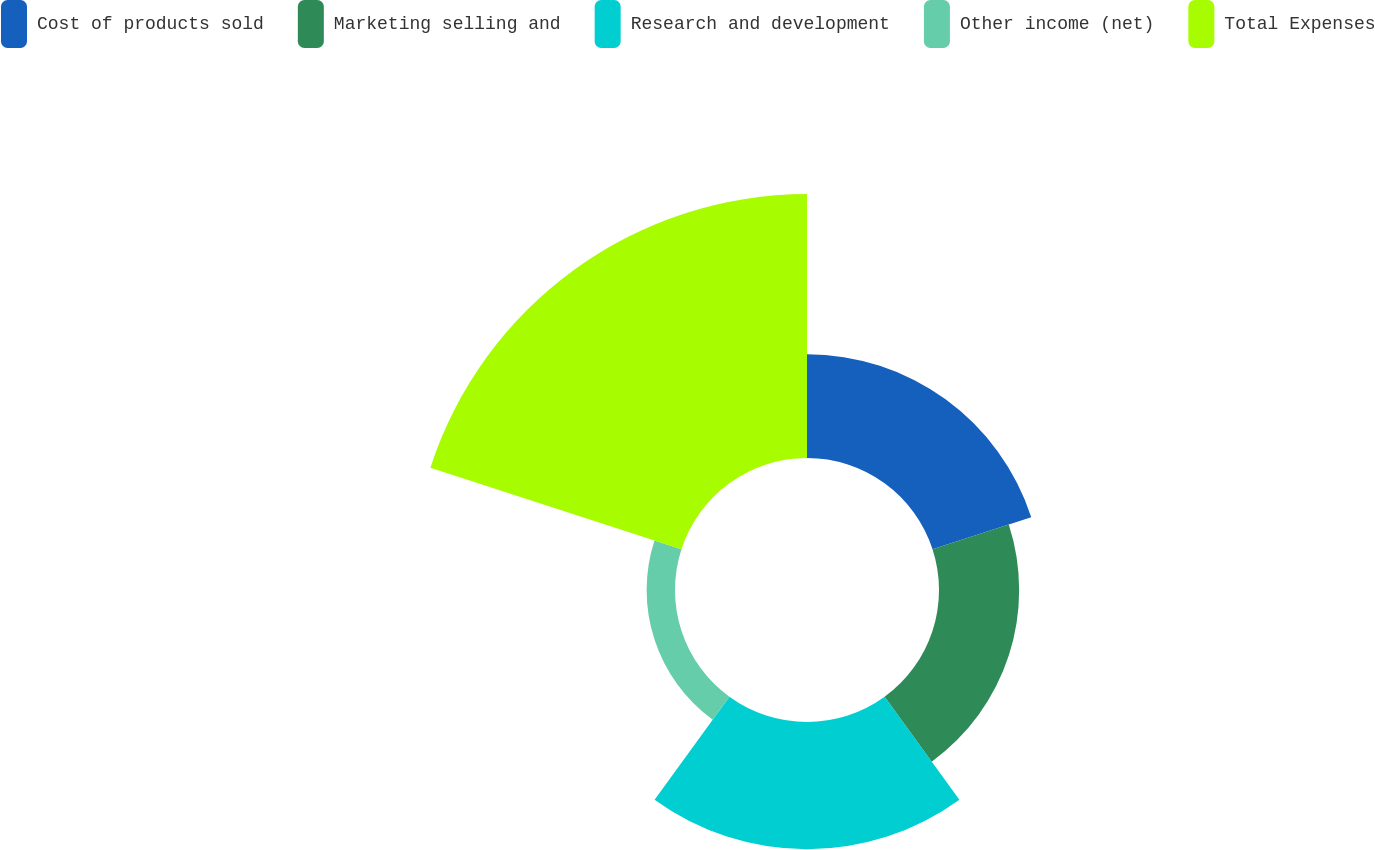Convert chart. <chart><loc_0><loc_0><loc_500><loc_500><pie_chart><fcel>Cost of products sold<fcel>Marketing selling and<fcel>Research and development<fcel>Other income (net)<fcel>Total Expenses<nl><fcel>17.19%<fcel>13.28%<fcel>21.09%<fcel>4.7%<fcel>43.74%<nl></chart> 